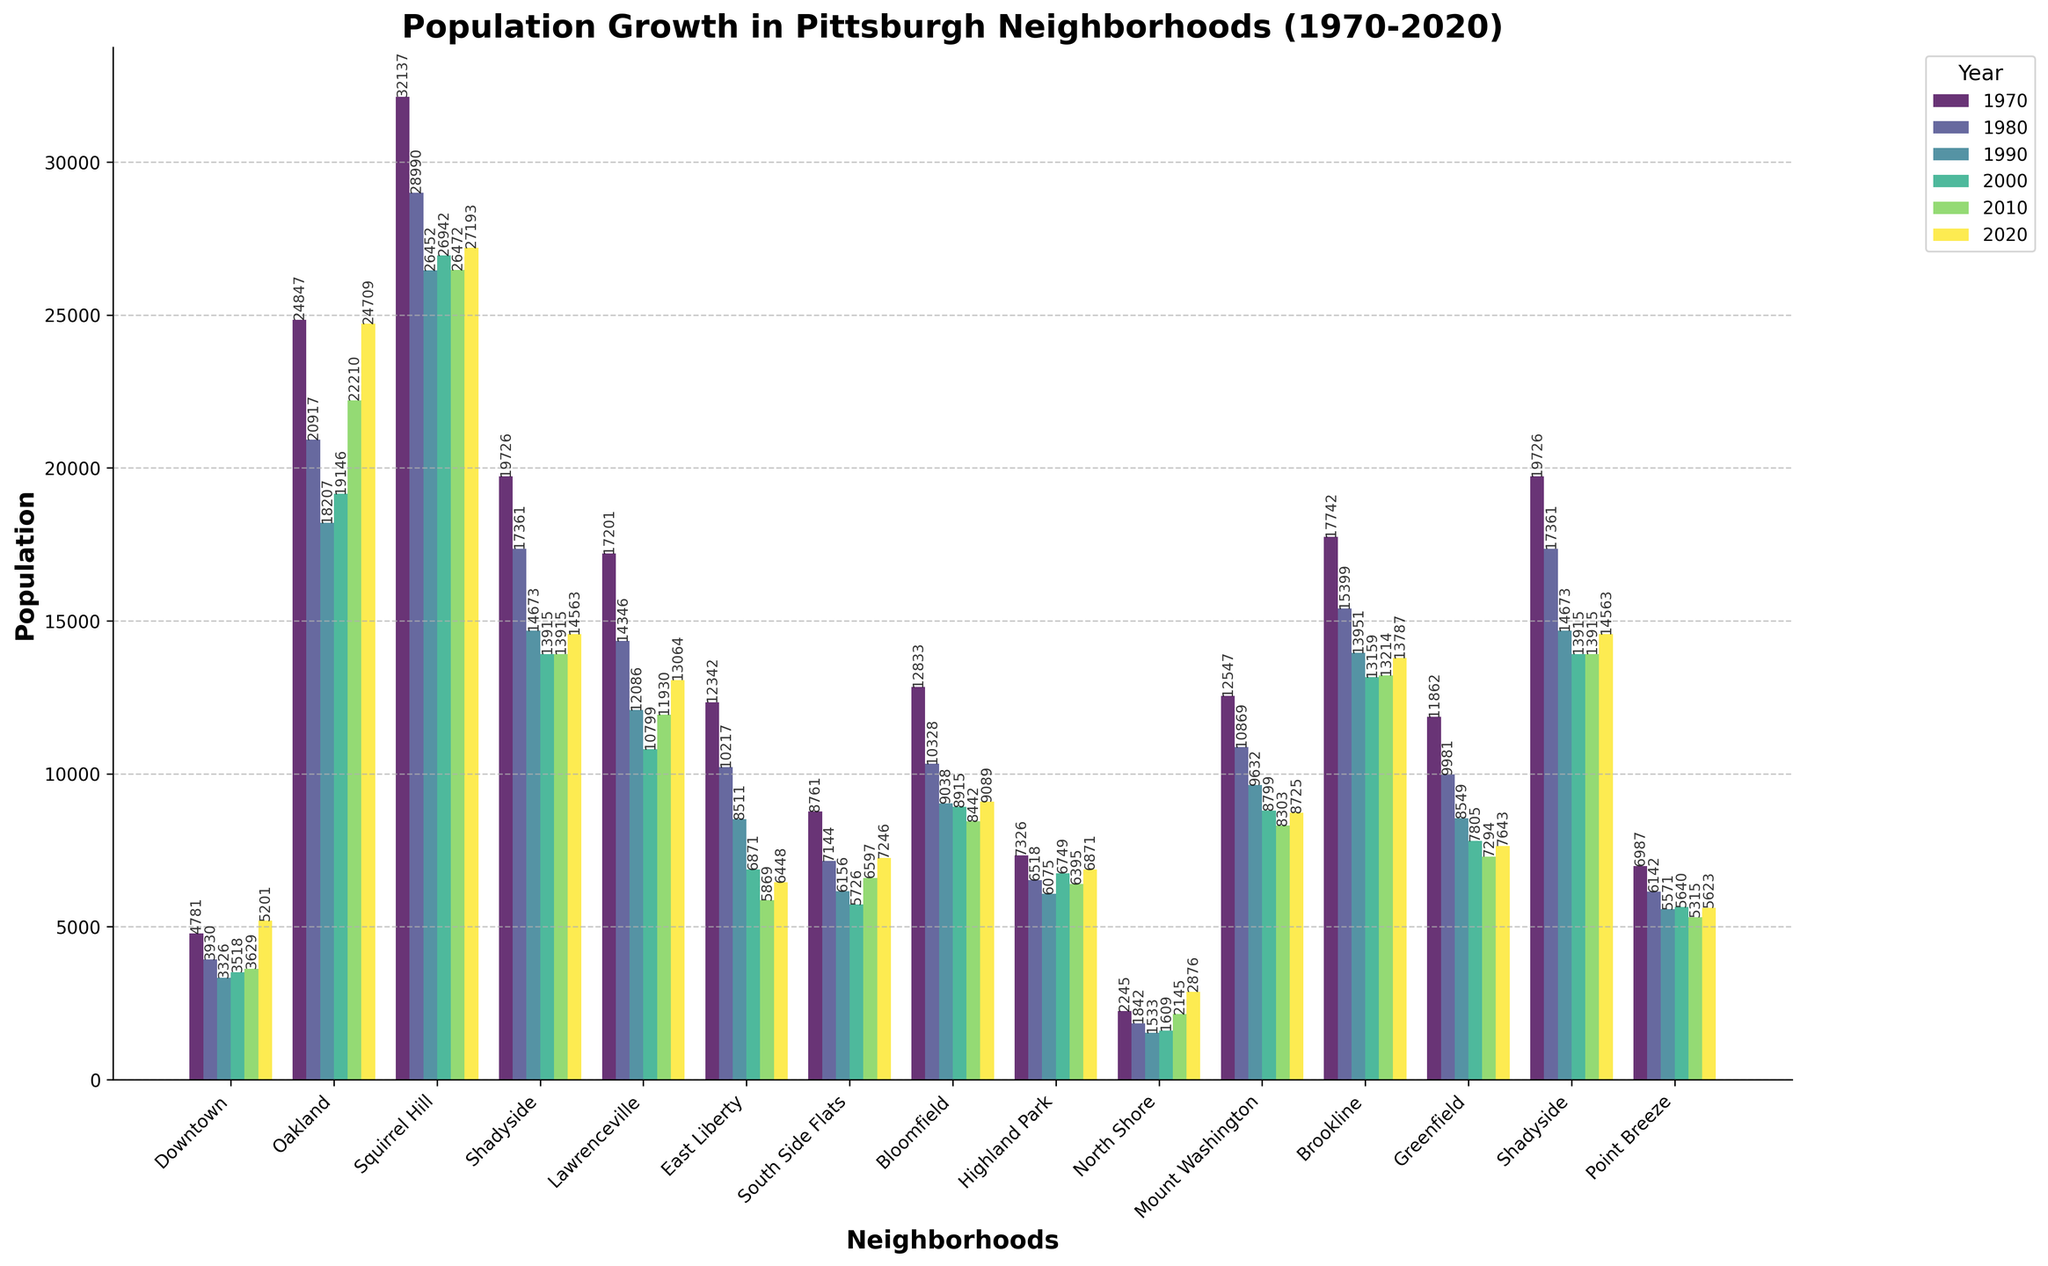Which neighborhood had the highest population growth from 2010 to 2020? Downtown had a population of 3629 in 2010 and 5201 in 2020. The growth is 5201 - 3629 = 1572. No other neighborhood shows a higher increase.
Answer: Downtown Which two neighborhoods had the most similar population counts in 2020? Look at the 2020 values and compare them. Lawrenceville and Bloomfield have 13064 and 9089, Shadyside and Point Breeze have 14563 and 5623, etc. South Side Flats and Highland Park have 7246 and 6871, respectively, which differ by only 375.
Answer: South Side Flats and Highland Park What's the average population of Oakland across all years shown? Oakland's population values are: 24847, 20917, 18207, 19146, 22210, 24709. Sum these up = 130036. Divide by the number of years = 130036 / 6 = 21672.67
Answer: 21672.67 Which neighborhood had the greatest population decline from 1970 to 2020? Compare (1970-2020) across all neighborhoods. For example, Downtown = 4781 - 5201 = -420, Oakland = 24847 - 24709 = 138, Squirrel Hill = 32137 - 27193 = 4944, etc. East Liberty has the highest decline: 12342 - 6448 = 5894.
Answer: East Liberty Which year saw the highest population in Squirrel Hill? Check Squirrel Hill’s values: 32137 (1970), 28990 (1980), 26452 (1990), 26942 (2000), 26472 (2010), 27193 (2020). The highest value is in 1970.
Answer: 1970 How did the population of the North Shore change from 1990 to 2020? North Shore's population: 1533 (1990), 1609 (2000), 2145 (2010), 2876 (2020). The change = 2876 - 1533 = 1343.
Answer: 1343 Which neighborhood showed the least change in population from 1970 to 2020? Calculate absolute changes for each neighborhood: Downtown = 420, Oakland = 138, Squirrel Hill = 4944, etc. Shadyside shows the least change:
Answer: 1163 Between 2000 and 2010, which neighborhood had a population increase while others declined? Compare 2000 and 2010 values across neighborhoods. Downtown = 3518 to 3629 (up by 111), Oakland = 19146 to 22210 (up by 3064), Squirrel Hill, etc. Oakland increased significantly.
Answer: Oakland 